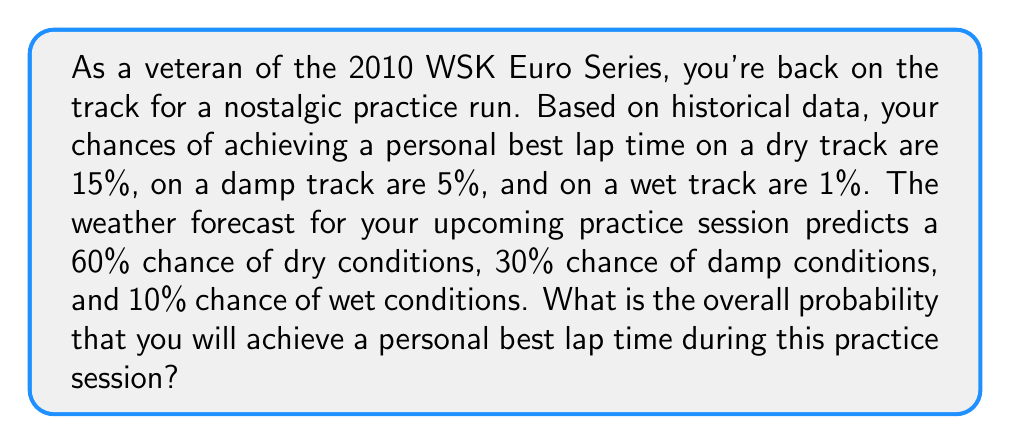Can you answer this question? To solve this problem, we'll use the law of total probability. Let's break it down step-by-step:

1) Let's define our events:
   A: Achieving a personal best lap time
   D: Dry track conditions
   M: Damp track conditions
   W: Wet track conditions

2) We're given the following probabilities:
   $P(A|D) = 0.15$ (probability of achieving best time given dry conditions)
   $P(A|M) = 0.05$ (probability of achieving best time given damp conditions)
   $P(A|W) = 0.01$ (probability of achieving best time given wet conditions)
   $P(D) = 0.60$ (probability of dry conditions)
   $P(M) = 0.30$ (probability of damp conditions)
   $P(W) = 0.10$ (probability of wet conditions)

3) The law of total probability states:
   $$P(A) = P(A|D)P(D) + P(A|M)P(M) + P(A|W)P(W)$$

4) Let's substitute our values:
   $$P(A) = (0.15)(0.60) + (0.05)(0.30) + (0.01)(0.10)$$

5) Now let's calculate:
   $$P(A) = 0.090 + 0.015 + 0.001$$

6) Adding these up:
   $$P(A) = 0.106$$

Therefore, the overall probability of achieving a personal best lap time is 0.106 or 10.6%.
Answer: 0.106 or 10.6% 